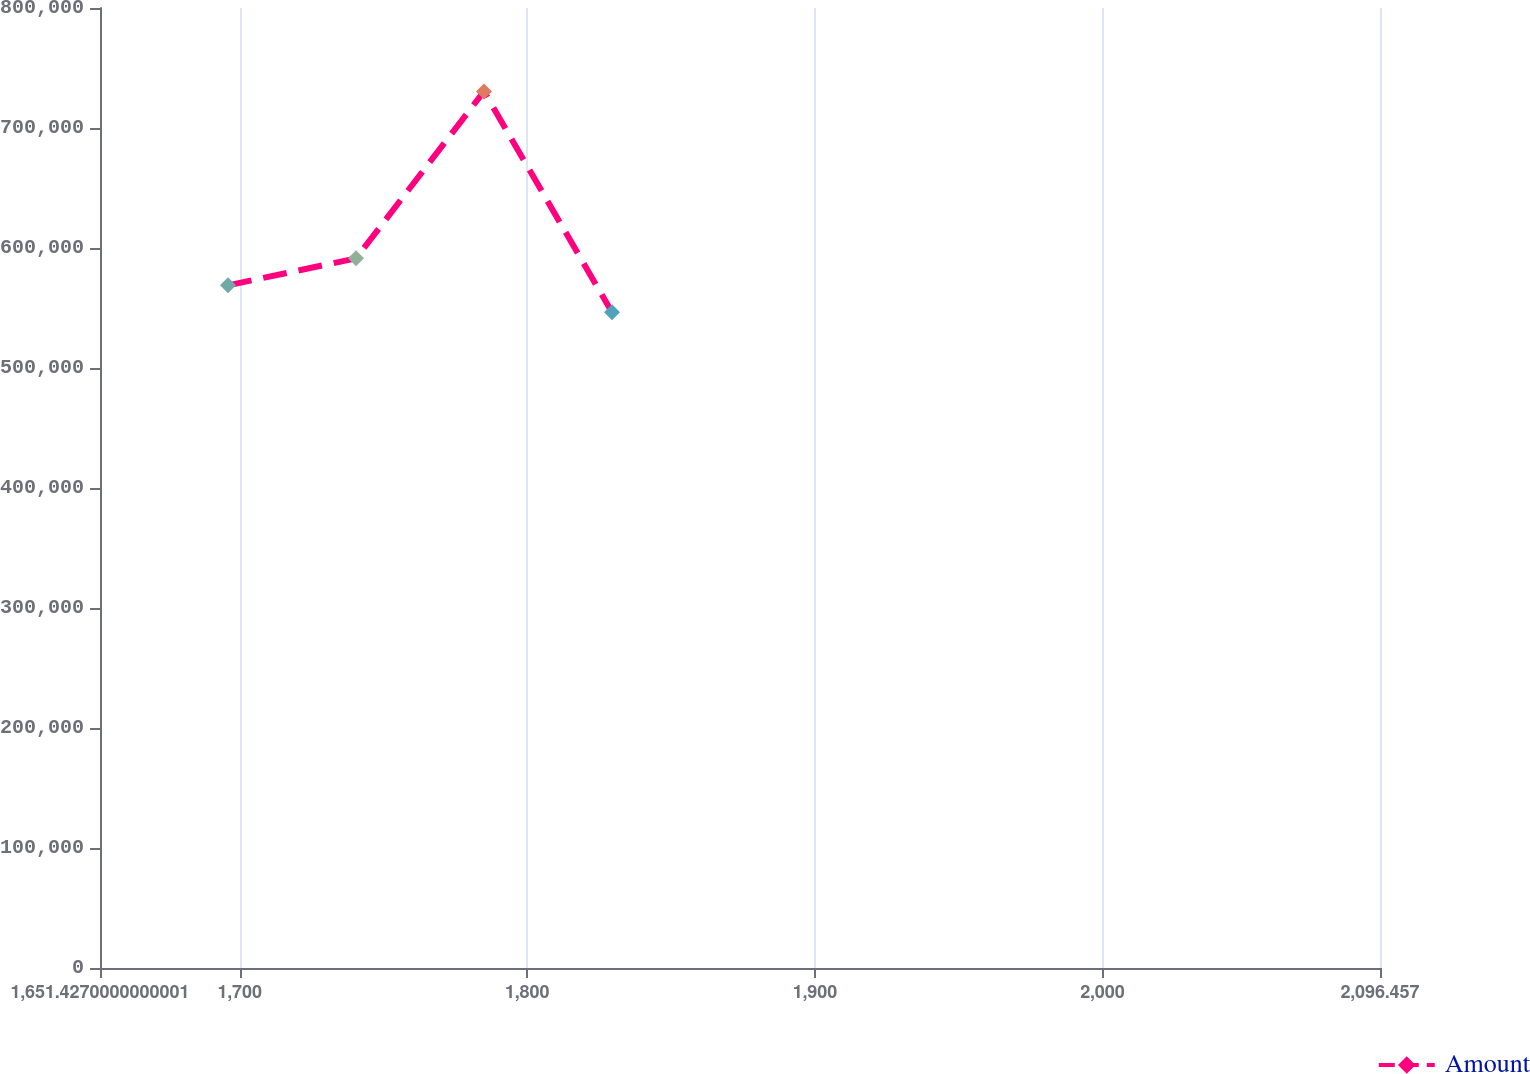Convert chart to OTSL. <chart><loc_0><loc_0><loc_500><loc_500><line_chart><ecel><fcel>Amount<nl><fcel>1695.93<fcel>568893<nl><fcel>1740.43<fcel>591358<nl><fcel>1784.93<fcel>730474<nl><fcel>1829.43<fcel>546427<nl><fcel>2140.96<fcel>771084<nl></chart> 